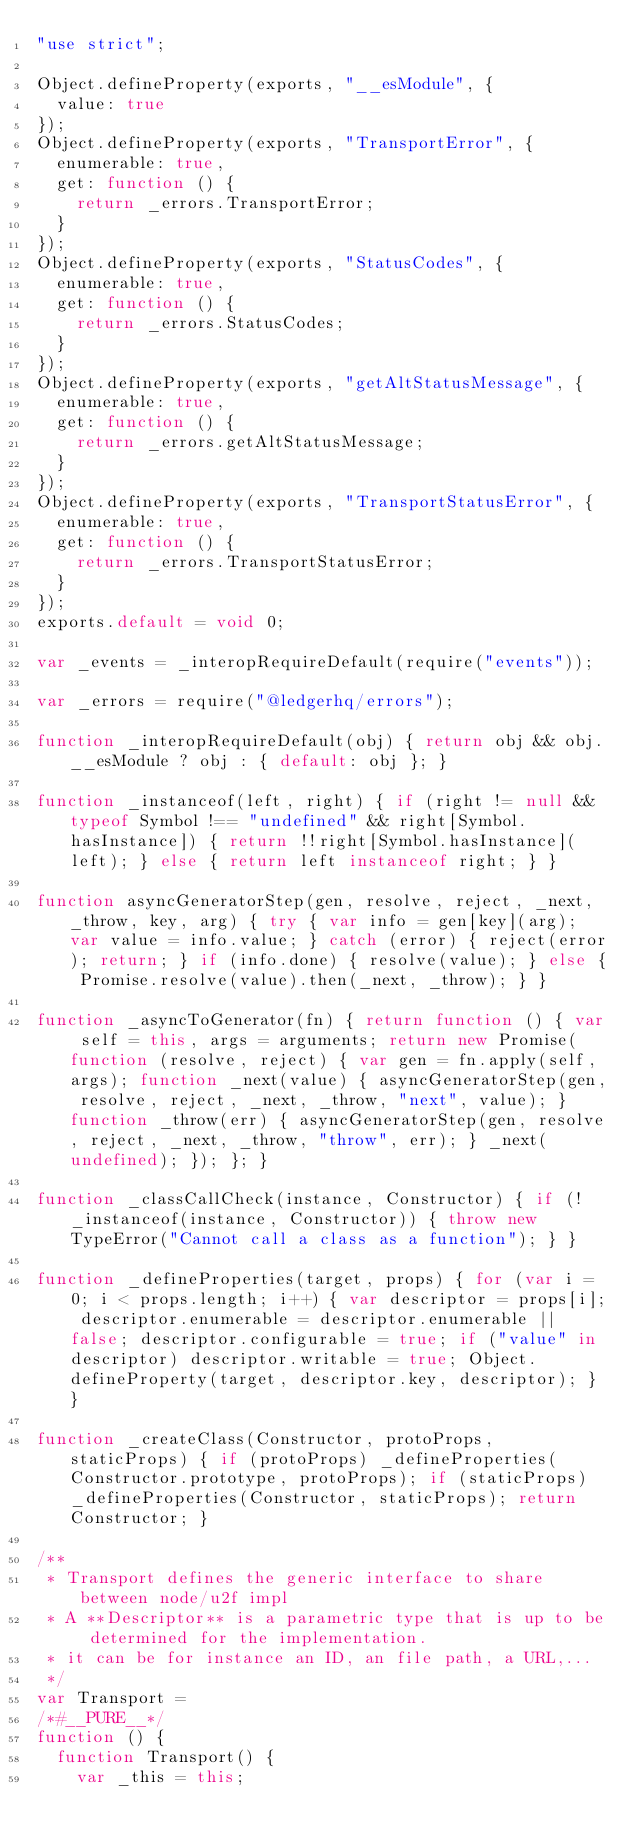Convert code to text. <code><loc_0><loc_0><loc_500><loc_500><_JavaScript_>"use strict";

Object.defineProperty(exports, "__esModule", {
  value: true
});
Object.defineProperty(exports, "TransportError", {
  enumerable: true,
  get: function () {
    return _errors.TransportError;
  }
});
Object.defineProperty(exports, "StatusCodes", {
  enumerable: true,
  get: function () {
    return _errors.StatusCodes;
  }
});
Object.defineProperty(exports, "getAltStatusMessage", {
  enumerable: true,
  get: function () {
    return _errors.getAltStatusMessage;
  }
});
Object.defineProperty(exports, "TransportStatusError", {
  enumerable: true,
  get: function () {
    return _errors.TransportStatusError;
  }
});
exports.default = void 0;

var _events = _interopRequireDefault(require("events"));

var _errors = require("@ledgerhq/errors");

function _interopRequireDefault(obj) { return obj && obj.__esModule ? obj : { default: obj }; }

function _instanceof(left, right) { if (right != null && typeof Symbol !== "undefined" && right[Symbol.hasInstance]) { return !!right[Symbol.hasInstance](left); } else { return left instanceof right; } }

function asyncGeneratorStep(gen, resolve, reject, _next, _throw, key, arg) { try { var info = gen[key](arg); var value = info.value; } catch (error) { reject(error); return; } if (info.done) { resolve(value); } else { Promise.resolve(value).then(_next, _throw); } }

function _asyncToGenerator(fn) { return function () { var self = this, args = arguments; return new Promise(function (resolve, reject) { var gen = fn.apply(self, args); function _next(value) { asyncGeneratorStep(gen, resolve, reject, _next, _throw, "next", value); } function _throw(err) { asyncGeneratorStep(gen, resolve, reject, _next, _throw, "throw", err); } _next(undefined); }); }; }

function _classCallCheck(instance, Constructor) { if (!_instanceof(instance, Constructor)) { throw new TypeError("Cannot call a class as a function"); } }

function _defineProperties(target, props) { for (var i = 0; i < props.length; i++) { var descriptor = props[i]; descriptor.enumerable = descriptor.enumerable || false; descriptor.configurable = true; if ("value" in descriptor) descriptor.writable = true; Object.defineProperty(target, descriptor.key, descriptor); } }

function _createClass(Constructor, protoProps, staticProps) { if (protoProps) _defineProperties(Constructor.prototype, protoProps); if (staticProps) _defineProperties(Constructor, staticProps); return Constructor; }

/**
 * Transport defines the generic interface to share between node/u2f impl
 * A **Descriptor** is a parametric type that is up to be determined for the implementation.
 * it can be for instance an ID, an file path, a URL,...
 */
var Transport =
/*#__PURE__*/
function () {
  function Transport() {
    var _this = this;
</code> 